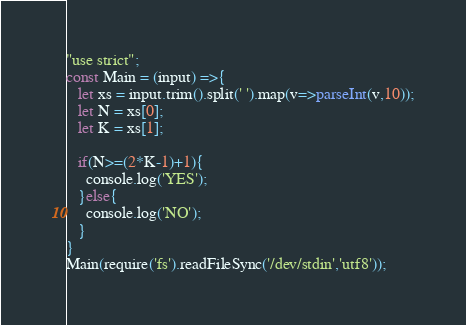Convert code to text. <code><loc_0><loc_0><loc_500><loc_500><_TypeScript_>"use strict";
const Main = (input) =>{
   let xs = input.trim().split(' ').map(v=>parseInt(v,10));
   let N = xs[0];
   let K = xs[1];
   
   if(N>=(2*K-1)+1){
     console.log('YES');
   }else{
     console.log('NO');
   }
}
Main(require('fs').readFileSync('/dev/stdin','utf8'));</code> 